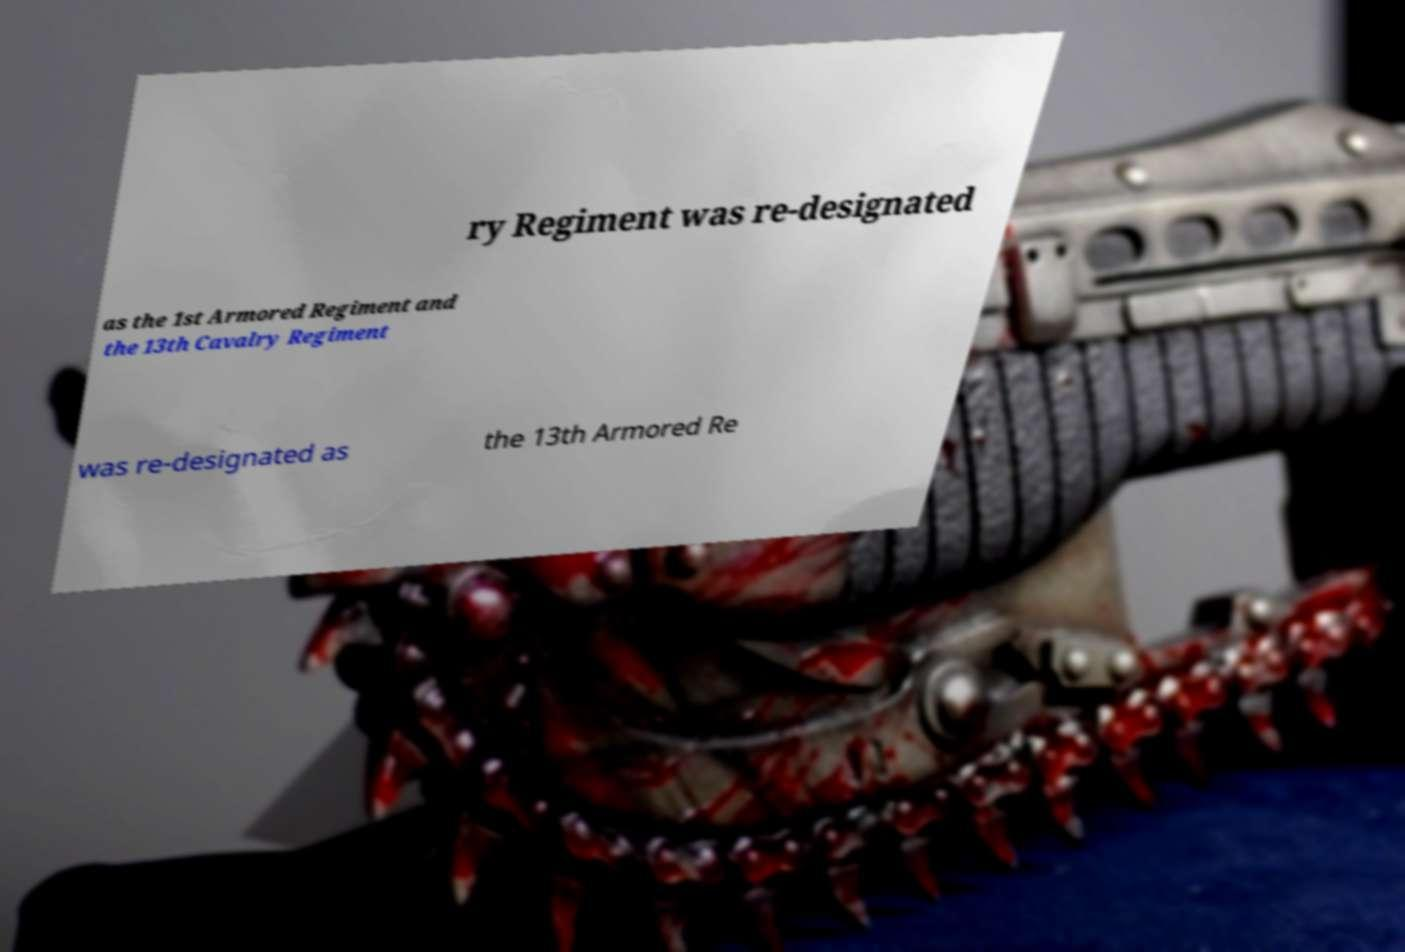For documentation purposes, I need the text within this image transcribed. Could you provide that? ry Regiment was re-designated as the 1st Armored Regiment and the 13th Cavalry Regiment was re-designated as the 13th Armored Re 